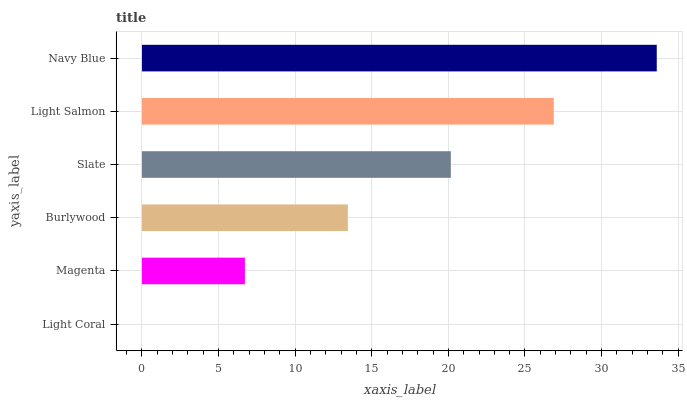Is Light Coral the minimum?
Answer yes or no. Yes. Is Navy Blue the maximum?
Answer yes or no. Yes. Is Magenta the minimum?
Answer yes or no. No. Is Magenta the maximum?
Answer yes or no. No. Is Magenta greater than Light Coral?
Answer yes or no. Yes. Is Light Coral less than Magenta?
Answer yes or no. Yes. Is Light Coral greater than Magenta?
Answer yes or no. No. Is Magenta less than Light Coral?
Answer yes or no. No. Is Slate the high median?
Answer yes or no. Yes. Is Burlywood the low median?
Answer yes or no. Yes. Is Magenta the high median?
Answer yes or no. No. Is Navy Blue the low median?
Answer yes or no. No. 